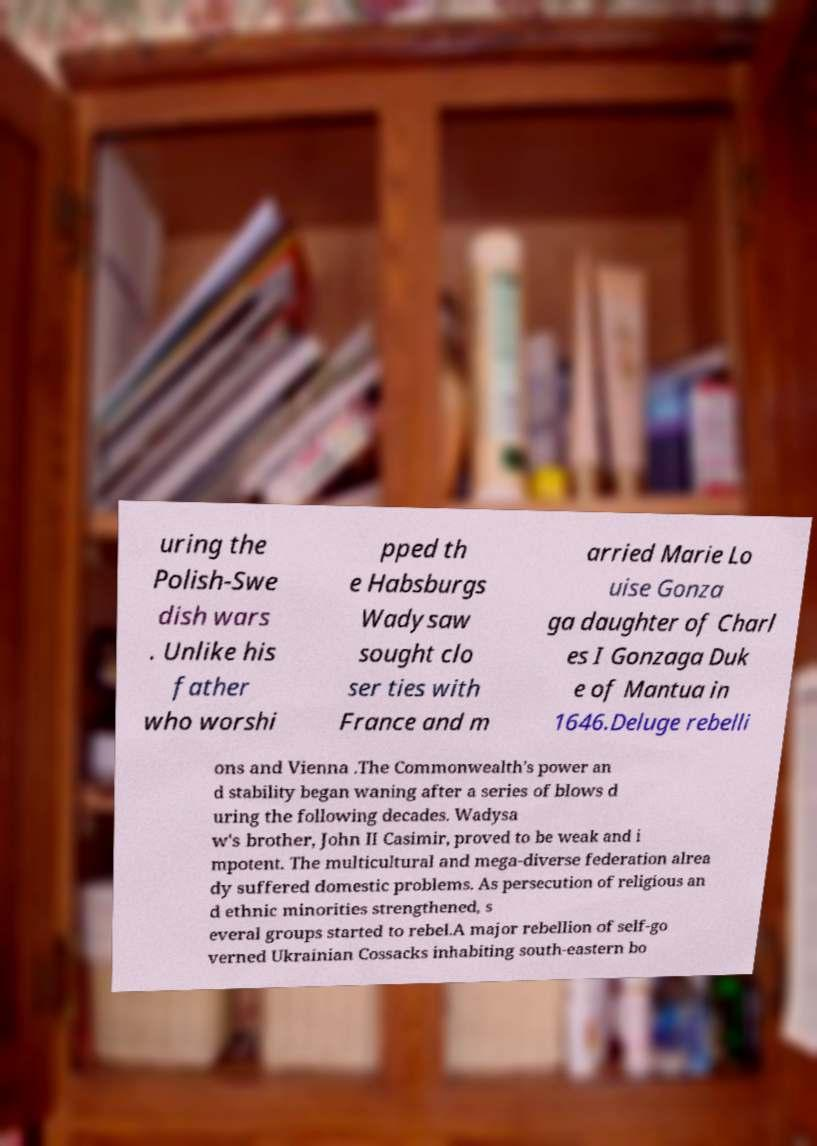Can you read and provide the text displayed in the image?This photo seems to have some interesting text. Can you extract and type it out for me? uring the Polish-Swe dish wars . Unlike his father who worshi pped th e Habsburgs Wadysaw sought clo ser ties with France and m arried Marie Lo uise Gonza ga daughter of Charl es I Gonzaga Duk e of Mantua in 1646.Deluge rebelli ons and Vienna .The Commonwealth's power an d stability began waning after a series of blows d uring the following decades. Wadysa w's brother, John II Casimir, proved to be weak and i mpotent. The multicultural and mega-diverse federation alrea dy suffered domestic problems. As persecution of religious an d ethnic minorities strengthened, s everal groups started to rebel.A major rebellion of self-go verned Ukrainian Cossacks inhabiting south-eastern bo 